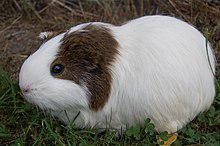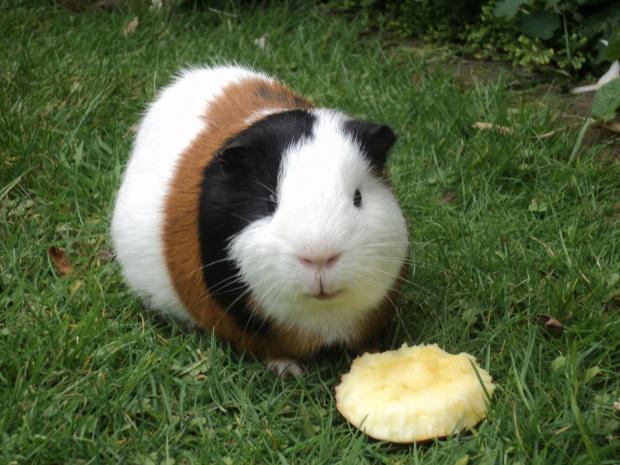The first image is the image on the left, the second image is the image on the right. For the images shown, is this caption "At least one hamster is eating something in at least one of the images." true? Answer yes or no. No. The first image is the image on the left, the second image is the image on the right. Considering the images on both sides, is "Each image contains a single guinea pig and only one guinea pig is standing on green grass." valid? Answer yes or no. No. 